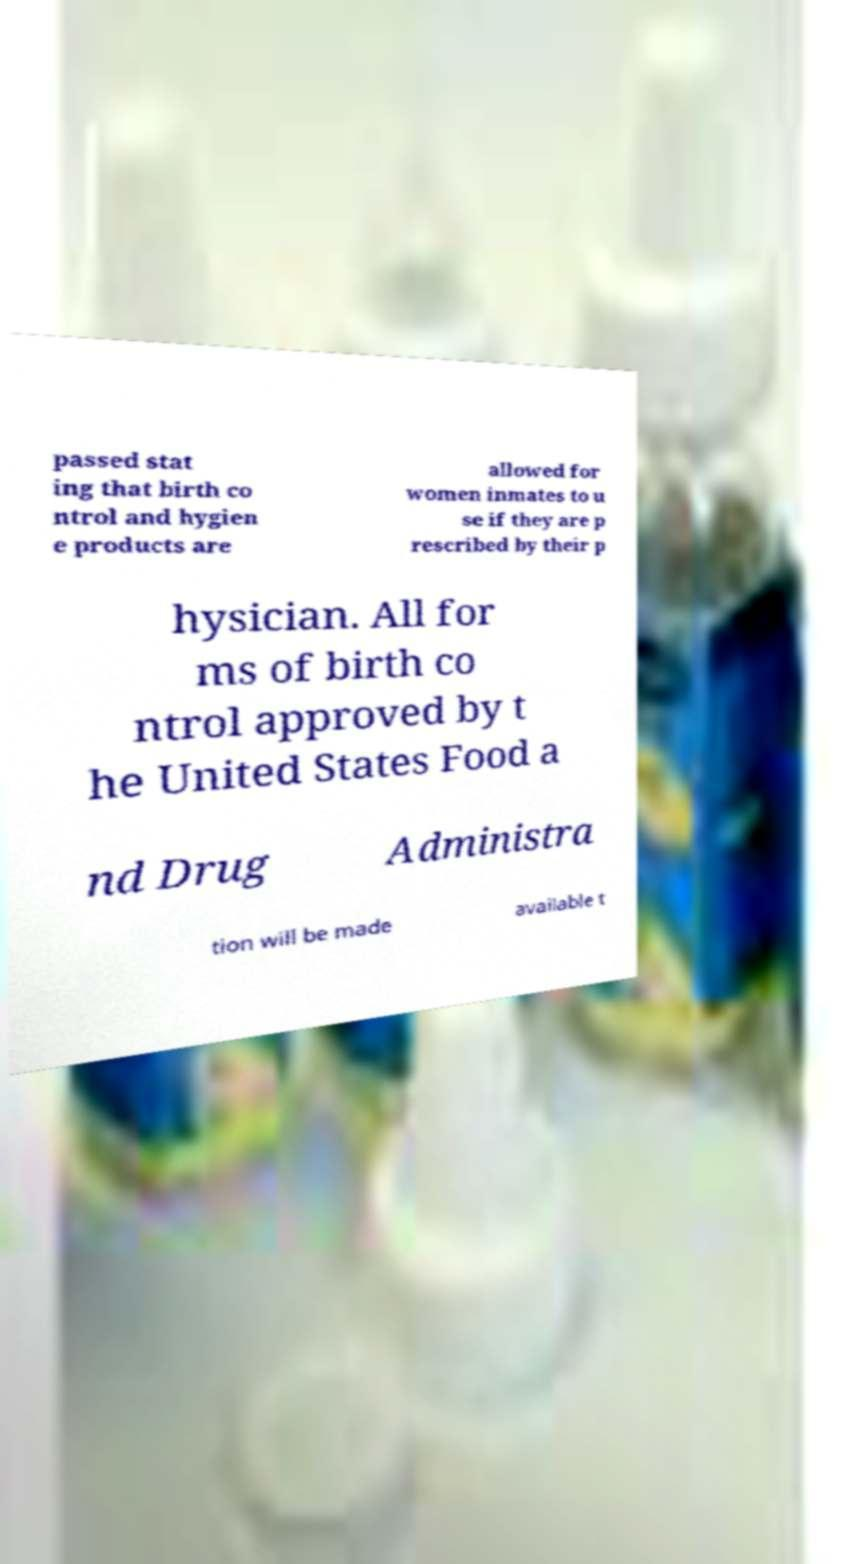Could you extract and type out the text from this image? passed stat ing that birth co ntrol and hygien e products are allowed for women inmates to u se if they are p rescribed by their p hysician. All for ms of birth co ntrol approved by t he United States Food a nd Drug Administra tion will be made available t 